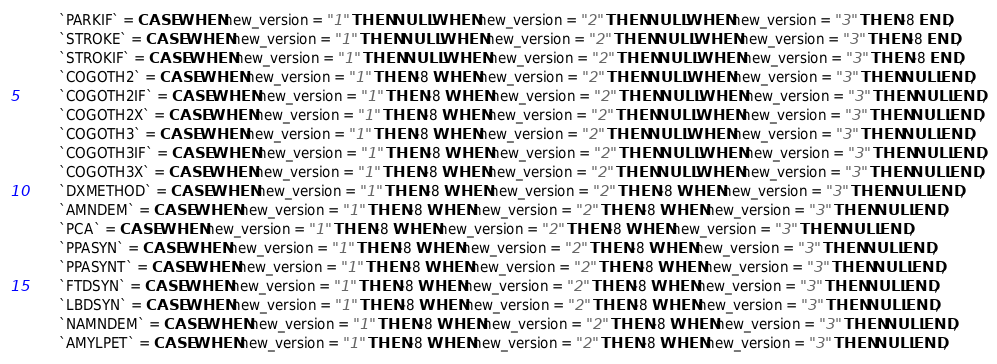<code> <loc_0><loc_0><loc_500><loc_500><_SQL_>		`PARKIF` = CASE WHEN new_version = "1" THEN NULL WHEN new_version = "2" THEN NULL WHEN new_version = "3" THEN -8 END,
		`STROKE` = CASE WHEN new_version = "1" THEN NULL WHEN new_version = "2" THEN NULL WHEN new_version = "3" THEN -8 END,
		`STROKIF` = CASE WHEN new_version = "1" THEN NULL WHEN new_version = "2" THEN NULL WHEN new_version = "3" THEN -8 END,
		`COGOTH2` = CASE WHEN new_version = "1" THEN -8 WHEN new_version = "2" THEN NULL WHEN new_version = "3" THEN NULL END,
		`COGOTH2IF` = CASE WHEN new_version = "1" THEN -8 WHEN new_version = "2" THEN NULL WHEN new_version = "3" THEN NULL END,
		`COGOTH2X` = CASE WHEN new_version = "1" THEN -8 WHEN new_version = "2" THEN NULL WHEN new_version = "3" THEN NULL END,
		`COGOTH3` = CASE WHEN new_version = "1" THEN -8 WHEN new_version = "2" THEN NULL WHEN new_version = "3" THEN NULL END,
		`COGOTH3IF` = CASE WHEN new_version = "1" THEN -8 WHEN new_version = "2" THEN NULL WHEN new_version = "3" THEN NULL END,
		`COGOTH3X` = CASE WHEN new_version = "1" THEN -8 WHEN new_version = "2" THEN NULL WHEN new_version = "3" THEN NULL END,
		`DXMETHOD` = CASE WHEN new_version = "1" THEN -8 WHEN new_version = "2" THEN -8 WHEN new_version = "3" THEN NULL END,
		`AMNDEM` = CASE WHEN new_version = "1" THEN -8 WHEN new_version = "2" THEN -8 WHEN new_version = "3" THEN NULL END,
		`PCA` = CASE WHEN new_version = "1" THEN -8 WHEN new_version = "2" THEN -8 WHEN new_version = "3" THEN NULL END,
		`PPASYN` = CASE WHEN new_version = "1" THEN -8 WHEN new_version = "2" THEN -8 WHEN new_version = "3" THEN NULL END,
		`PPASYNT` = CASE WHEN new_version = "1" THEN -8 WHEN new_version = "2" THEN -8 WHEN new_version = "3" THEN NULL END,
		`FTDSYN` = CASE WHEN new_version = "1" THEN -8 WHEN new_version = "2" THEN -8 WHEN new_version = "3" THEN NULL END,
		`LBDSYN` = CASE WHEN new_version = "1" THEN -8 WHEN new_version = "2" THEN -8 WHEN new_version = "3" THEN NULL END,
		`NAMNDEM` = CASE WHEN new_version = "1" THEN -8 WHEN new_version = "2" THEN -8 WHEN new_version = "3" THEN NULL END,
		`AMYLPET` = CASE WHEN new_version = "1" THEN -8 WHEN new_version = "2" THEN -8 WHEN new_version = "3" THEN NULL END,</code> 